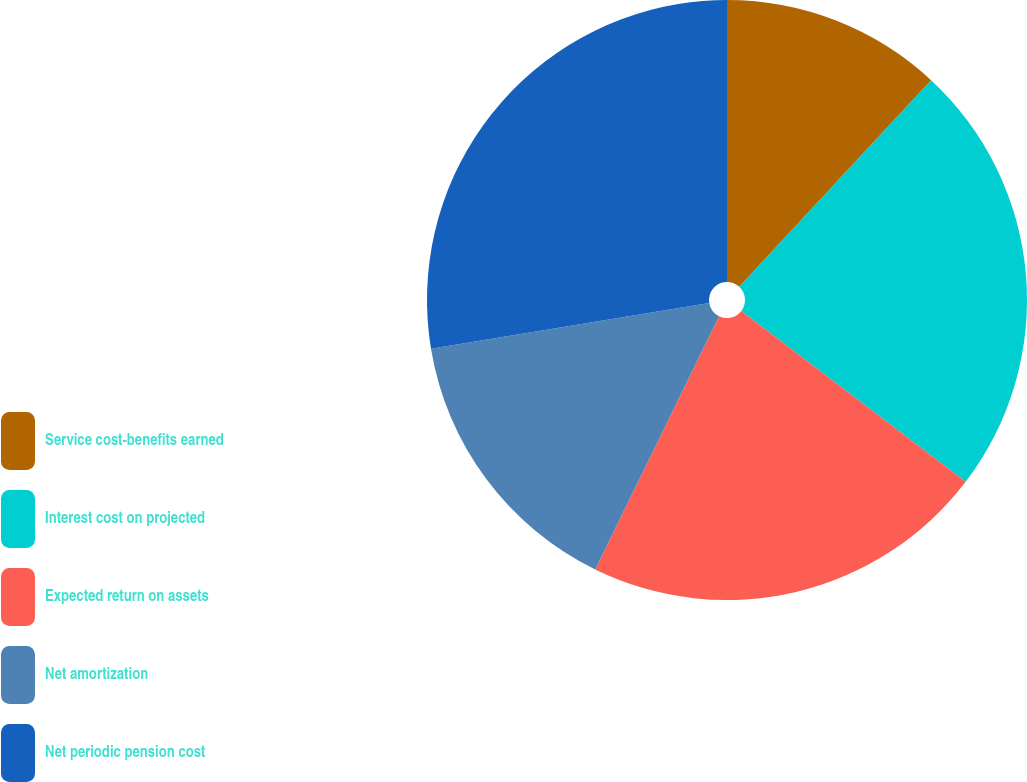Convert chart. <chart><loc_0><loc_0><loc_500><loc_500><pie_chart><fcel>Service cost-benefits earned<fcel>Interest cost on projected<fcel>Expected return on assets<fcel>Net amortization<fcel>Net periodic pension cost<nl><fcel>11.91%<fcel>23.45%<fcel>21.88%<fcel>15.16%<fcel>27.6%<nl></chart> 